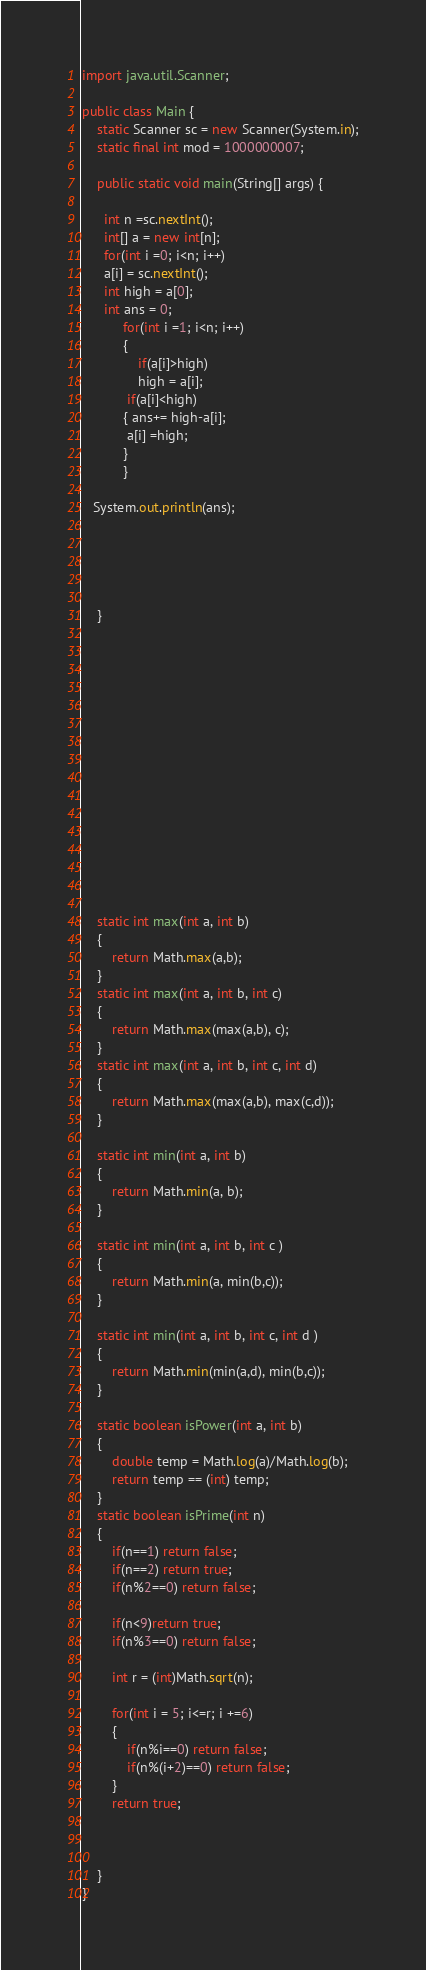Convert code to text. <code><loc_0><loc_0><loc_500><loc_500><_Java_>import java.util.Scanner;

public class Main {
    static Scanner sc = new Scanner(System.in);
    static final int mod = 1000000007;

    public static void main(String[] args) {

      int n =sc.nextInt();
      int[] a = new int[n];
      for(int i =0; i<n; i++)
      a[i] = sc.nextInt();
      int high = a[0];
      int ans = 0;
           for(int i =1; i<n; i++)
           {
               if(a[i]>high)
               high = a[i];
            if(a[i]<high)
           { ans+= high-a[i];
            a[i] =high; 
           }
           }
        
   System.out.println(ans);
        
       



    }
















    static int max(int a, int b)
    {
        return Math.max(a,b);
    }
    static int max(int a, int b, int c)
    {
        return Math.max(max(a,b), c);
    }
    static int max(int a, int b, int c, int d)
    {
        return Math.max(max(a,b), max(c,d));
    }

    static int min(int a, int b)
    {
        return Math.min(a, b);
    }

    static int min(int a, int b, int c )
    {
        return Math.min(a, min(b,c));
    }

    static int min(int a, int b, int c, int d )
    {
        return Math.min(min(a,d), min(b,c));
    }

    static boolean isPower(int a, int b)
    {
        double temp = Math.log(a)/Math.log(b);
        return temp == (int) temp;
    }
    static boolean isPrime(int n)
    {
        if(n==1) return false;
        if(n==2) return true;
        if(n%2==0) return false;

        if(n<9)return true;
        if(n%3==0) return false;

        int r = (int)Math.sqrt(n);

        for(int i = 5; i<=r; i +=6)
        {
            if(n%i==0) return false;
            if(n%(i+2)==0) return false;
        }
        return true;



    }
}
</code> 